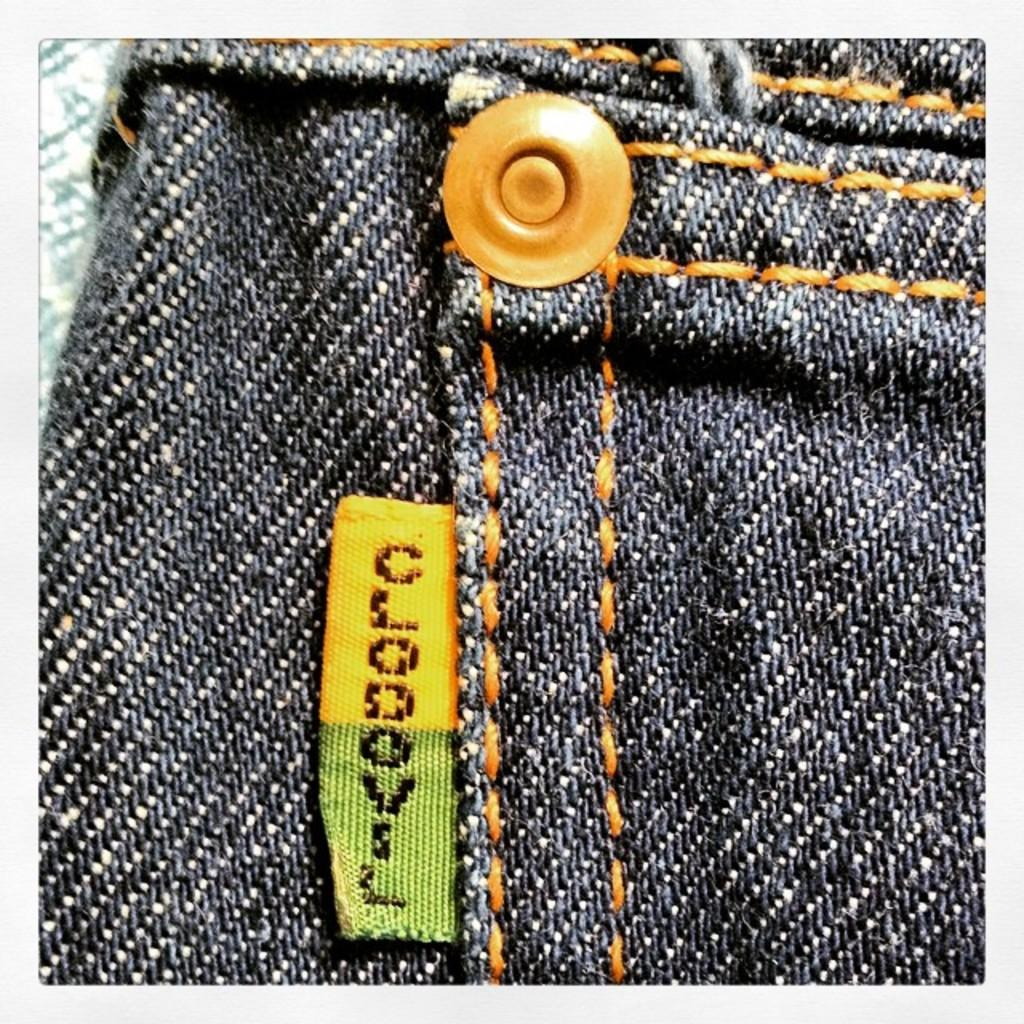What type of clothing item is visible in the image? There is a pair of jeans in the image. How many cats are sitting on the frame of the jeans in the image? There are no cats or frames present in the image; it only features a pair of jeans. 